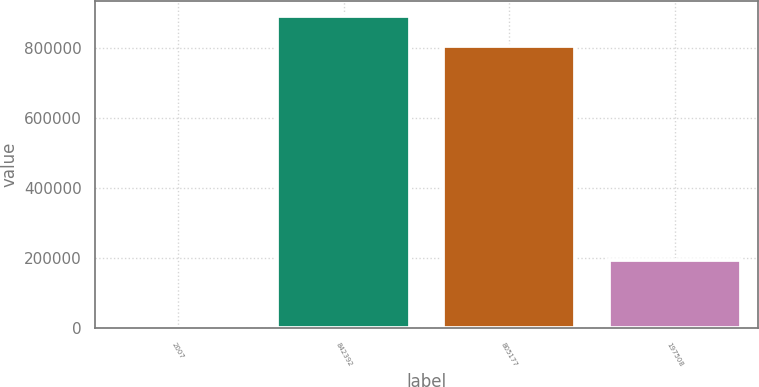Convert chart to OTSL. <chart><loc_0><loc_0><loc_500><loc_500><bar_chart><fcel>2007<fcel>842392<fcel>805177<fcel>197508<nl><fcel>2007<fcel>891051<fcel>806511<fcel>195835<nl></chart> 